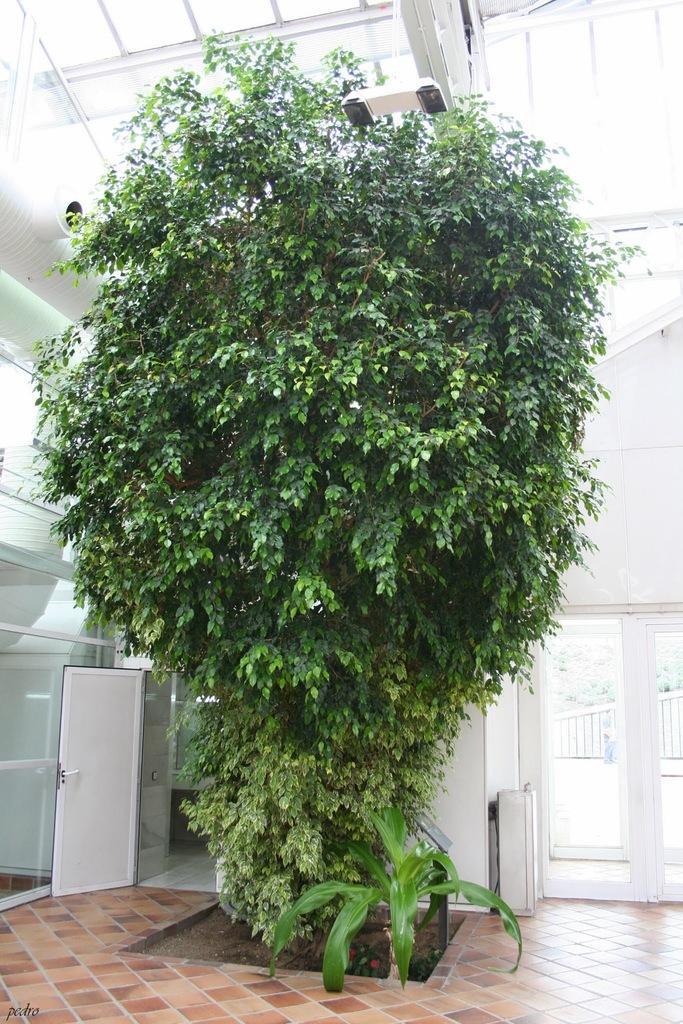Describe this image in one or two sentences. In this picture we can see the huge green plant in the front. Behind there is a glass door and white wall. On the top there is a glass shed. 